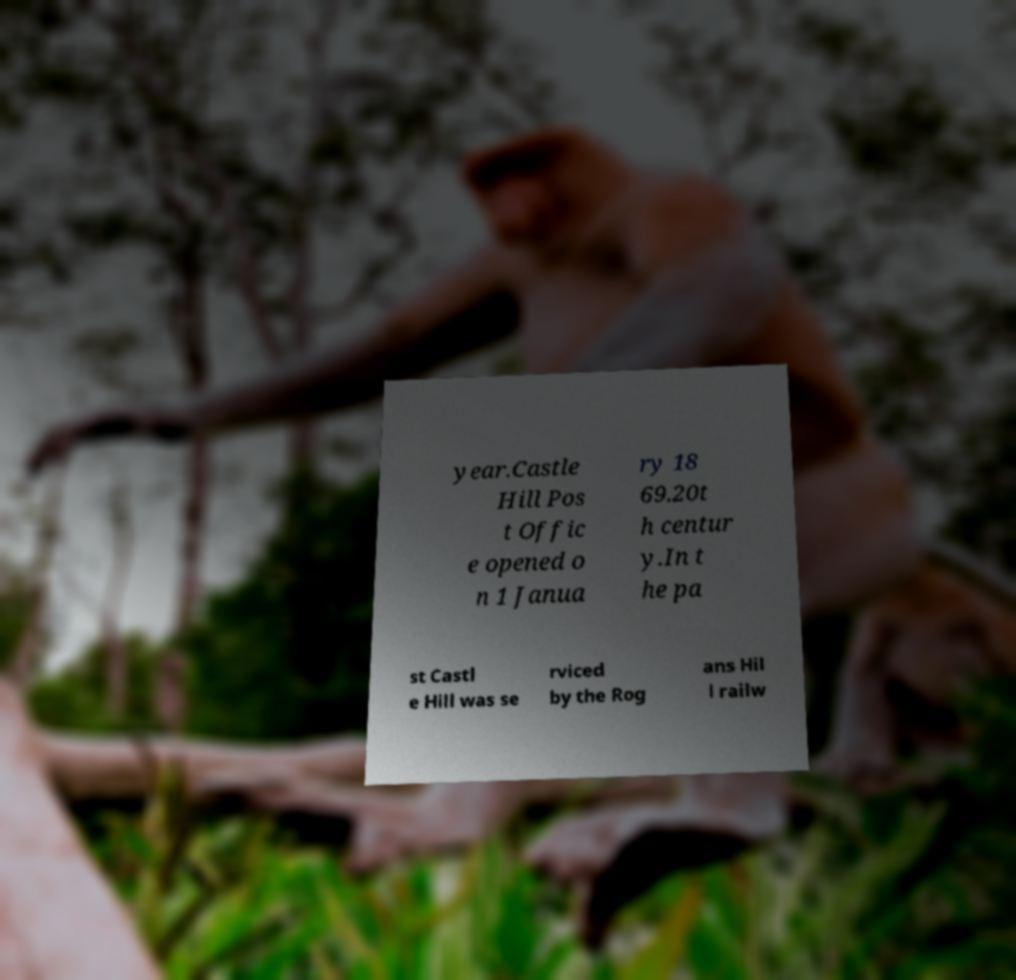For documentation purposes, I need the text within this image transcribed. Could you provide that? year.Castle Hill Pos t Offic e opened o n 1 Janua ry 18 69.20t h centur y.In t he pa st Castl e Hill was se rviced by the Rog ans Hil l railw 